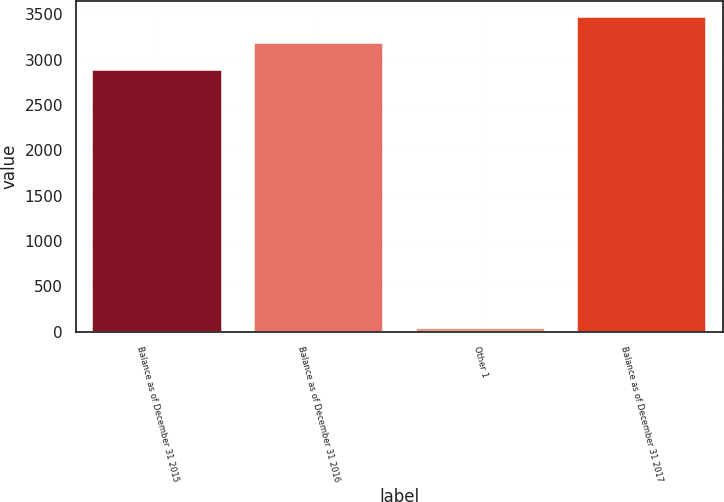Convert chart to OTSL. <chart><loc_0><loc_0><loc_500><loc_500><bar_chart><fcel>Balance as of December 31 2015<fcel>Balance as of December 31 2016<fcel>Other 1<fcel>Balance as of December 31 2017<nl><fcel>2882<fcel>3176.9<fcel>40<fcel>3471.8<nl></chart> 